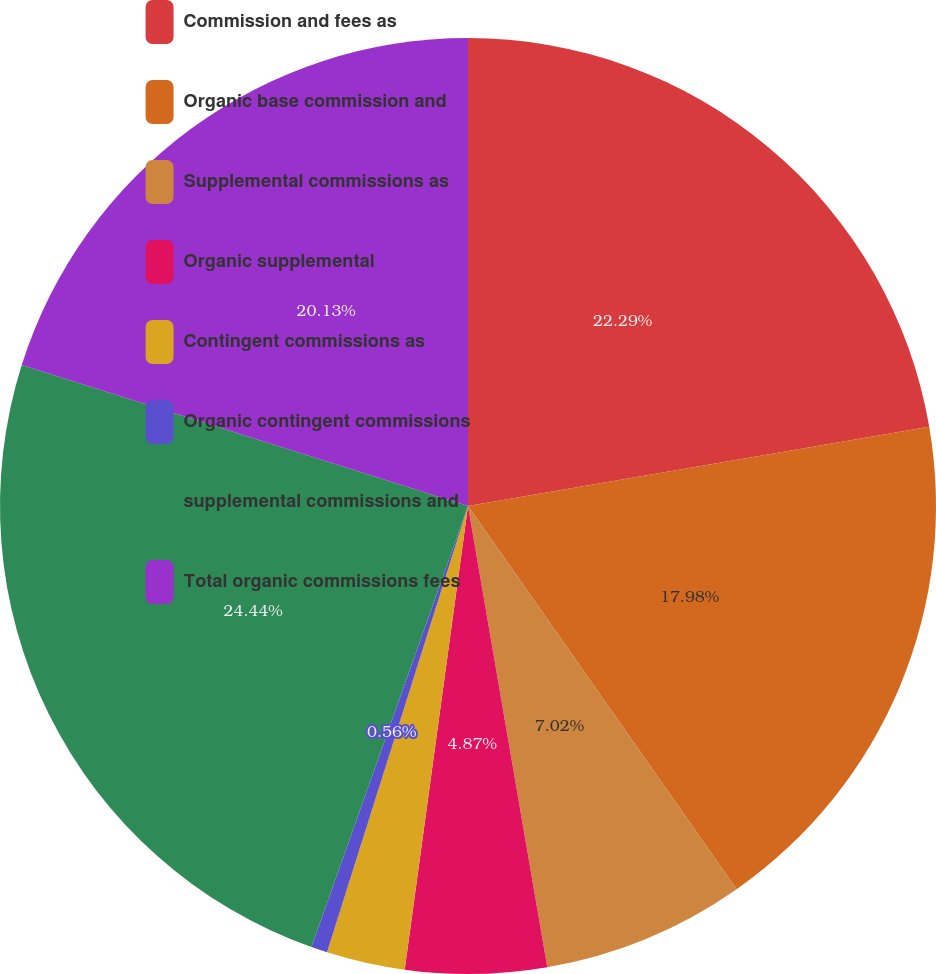Convert chart to OTSL. <chart><loc_0><loc_0><loc_500><loc_500><pie_chart><fcel>Commission and fees as<fcel>Organic base commission and<fcel>Supplemental commissions as<fcel>Organic supplemental<fcel>Contingent commissions as<fcel>Organic contingent commissions<fcel>supplemental commissions and<fcel>Total organic commissions fees<nl><fcel>22.29%<fcel>17.98%<fcel>7.02%<fcel>4.87%<fcel>2.71%<fcel>0.56%<fcel>24.44%<fcel>20.13%<nl></chart> 